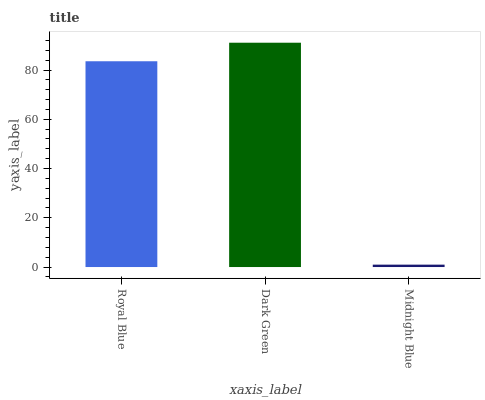Is Midnight Blue the minimum?
Answer yes or no. Yes. Is Dark Green the maximum?
Answer yes or no. Yes. Is Dark Green the minimum?
Answer yes or no. No. Is Midnight Blue the maximum?
Answer yes or no. No. Is Dark Green greater than Midnight Blue?
Answer yes or no. Yes. Is Midnight Blue less than Dark Green?
Answer yes or no. Yes. Is Midnight Blue greater than Dark Green?
Answer yes or no. No. Is Dark Green less than Midnight Blue?
Answer yes or no. No. Is Royal Blue the high median?
Answer yes or no. Yes. Is Royal Blue the low median?
Answer yes or no. Yes. Is Midnight Blue the high median?
Answer yes or no. No. Is Dark Green the low median?
Answer yes or no. No. 